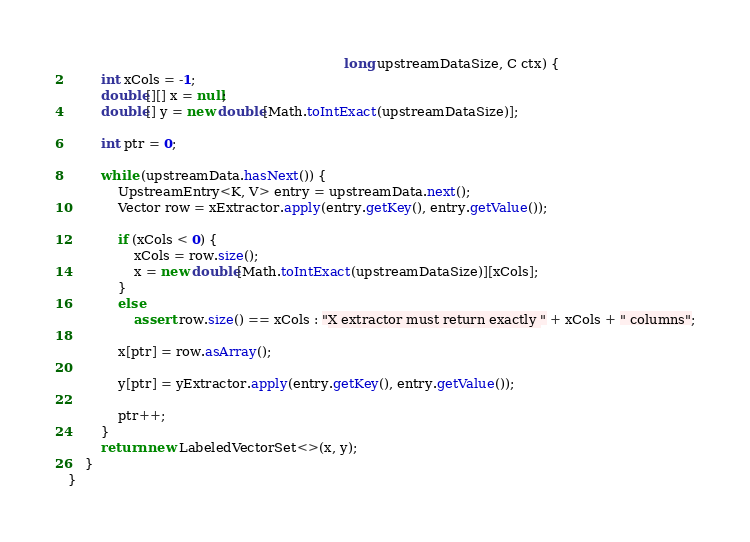Convert code to text. <code><loc_0><loc_0><loc_500><loc_500><_Java_>                                                                   long upstreamDataSize, C ctx) {
        int xCols = -1;
        double[][] x = null;
        double[] y = new double[Math.toIntExact(upstreamDataSize)];

        int ptr = 0;

        while (upstreamData.hasNext()) {
            UpstreamEntry<K, V> entry = upstreamData.next();
            Vector row = xExtractor.apply(entry.getKey(), entry.getValue());

            if (xCols < 0) {
                xCols = row.size();
                x = new double[Math.toIntExact(upstreamDataSize)][xCols];
            }
            else
                assert row.size() == xCols : "X extractor must return exactly " + xCols + " columns";

            x[ptr] = row.asArray();

            y[ptr] = yExtractor.apply(entry.getKey(), entry.getValue());

            ptr++;
        }
        return new LabeledVectorSet<>(x, y);
    }
}
</code> 